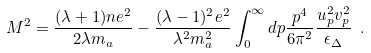<formula> <loc_0><loc_0><loc_500><loc_500>M ^ { 2 } = \frac { ( \lambda + 1 ) n e ^ { 2 } } { 2 \lambda m _ { a } } - \frac { ( \lambda - 1 ) ^ { 2 } e ^ { 2 } } { \lambda ^ { 2 } m _ { a } ^ { 2 } } \int _ { 0 } ^ { \infty } d p \frac { p ^ { 4 } } { 6 \pi ^ { 2 } } \frac { u _ { p } ^ { 2 } v _ { p } ^ { 2 } } { \epsilon _ { \Delta } } \ .</formula> 